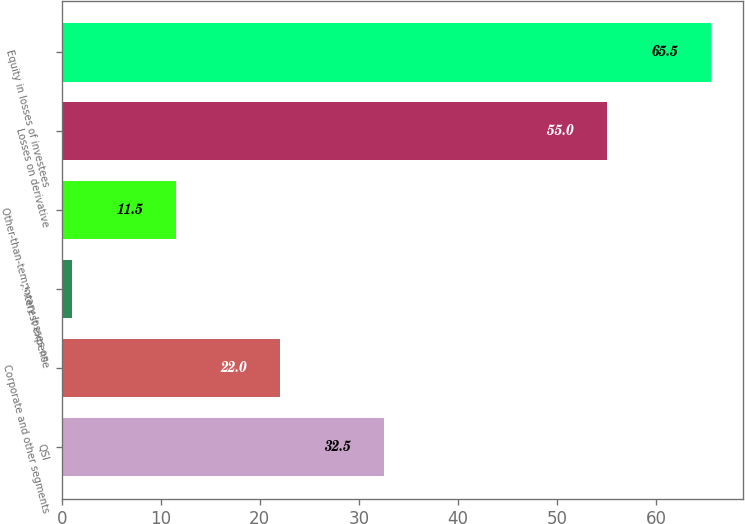Convert chart. <chart><loc_0><loc_0><loc_500><loc_500><bar_chart><fcel>QSI<fcel>Corporate and other segments<fcel>Interest expense<fcel>Other-than-temporary losses on<fcel>Losses on derivative<fcel>Equity in losses of investees<nl><fcel>32.5<fcel>22<fcel>1<fcel>11.5<fcel>55<fcel>65.5<nl></chart> 